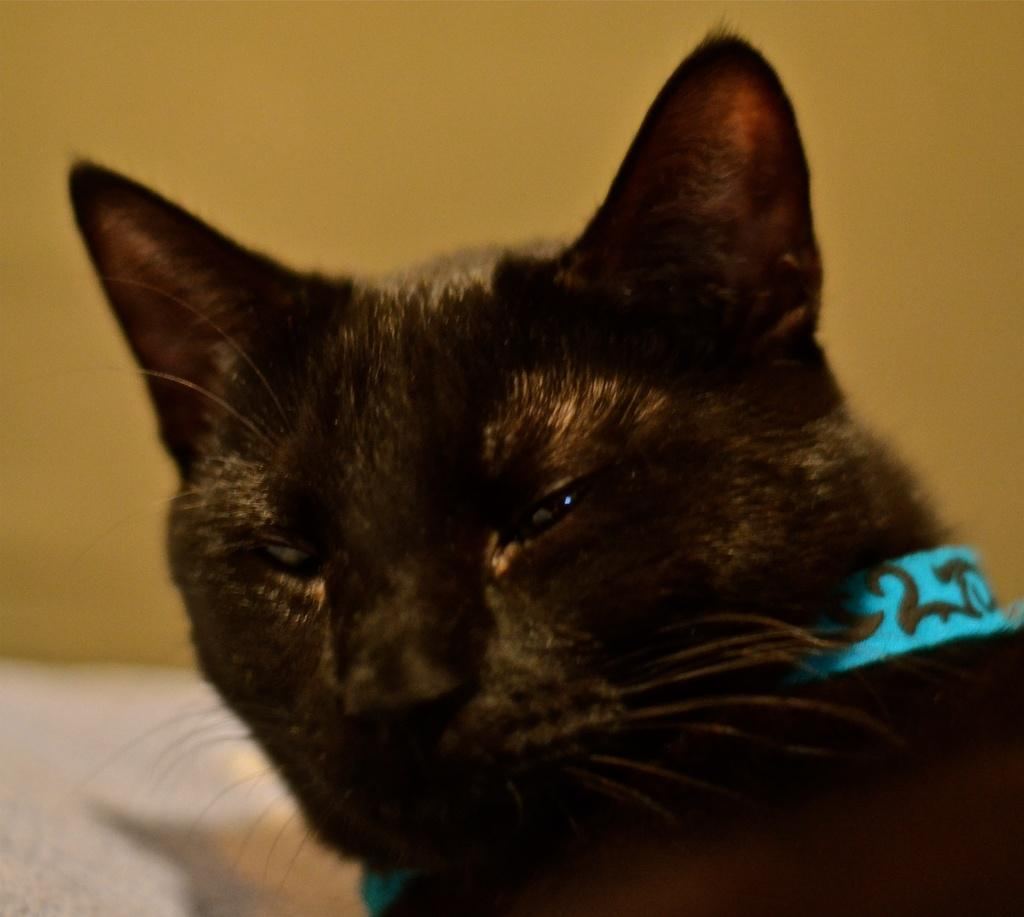What type of animal is in the image? There is a black cat in the image. Is there anything attached to the cat? Yes, the cat has a blue tag around its neck. What color is the background of the image? The background of the image is yellow. What type of engine is visible in the image? There is no engine present in the image; it features a black cat with a blue tag and a yellow background. 